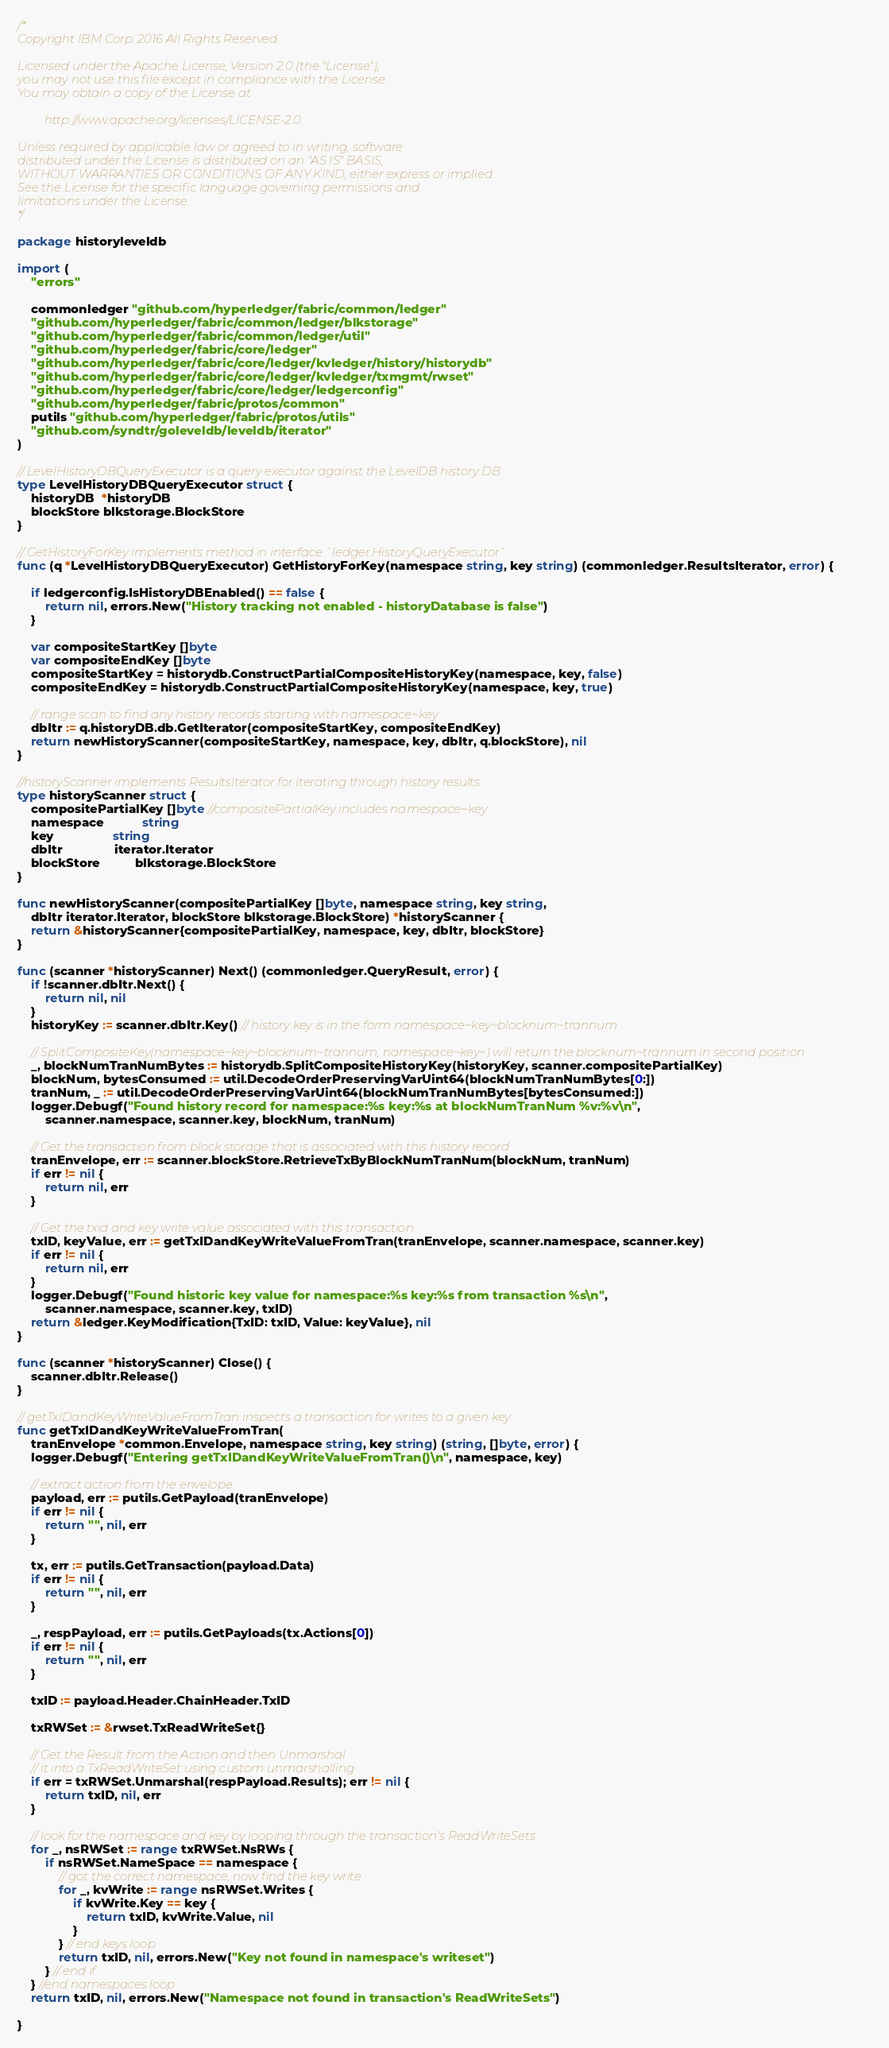Convert code to text. <code><loc_0><loc_0><loc_500><loc_500><_Go_>/*
Copyright IBM Corp. 2016 All Rights Reserved.

Licensed under the Apache License, Version 2.0 (the "License");
you may not use this file except in compliance with the License.
You may obtain a copy of the License at

		 http://www.apache.org/licenses/LICENSE-2.0

Unless required by applicable law or agreed to in writing, software
distributed under the License is distributed on an "AS IS" BASIS,
WITHOUT WARRANTIES OR CONDITIONS OF ANY KIND, either express or implied.
See the License for the specific language governing permissions and
limitations under the License.
*/

package historyleveldb

import (
	"errors"

	commonledger "github.com/hyperledger/fabric/common/ledger"
	"github.com/hyperledger/fabric/common/ledger/blkstorage"
	"github.com/hyperledger/fabric/common/ledger/util"
	"github.com/hyperledger/fabric/core/ledger"
	"github.com/hyperledger/fabric/core/ledger/kvledger/history/historydb"
	"github.com/hyperledger/fabric/core/ledger/kvledger/txmgmt/rwset"
	"github.com/hyperledger/fabric/core/ledger/ledgerconfig"
	"github.com/hyperledger/fabric/protos/common"
	putils "github.com/hyperledger/fabric/protos/utils"
	"github.com/syndtr/goleveldb/leveldb/iterator"
)

// LevelHistoryDBQueryExecutor is a query executor against the LevelDB history DB
type LevelHistoryDBQueryExecutor struct {
	historyDB  *historyDB
	blockStore blkstorage.BlockStore
}

// GetHistoryForKey implements method in interface `ledger.HistoryQueryExecutor`
func (q *LevelHistoryDBQueryExecutor) GetHistoryForKey(namespace string, key string) (commonledger.ResultsIterator, error) {

	if ledgerconfig.IsHistoryDBEnabled() == false {
		return nil, errors.New("History tracking not enabled - historyDatabase is false")
	}

	var compositeStartKey []byte
	var compositeEndKey []byte
	compositeStartKey = historydb.ConstructPartialCompositeHistoryKey(namespace, key, false)
	compositeEndKey = historydb.ConstructPartialCompositeHistoryKey(namespace, key, true)

	// range scan to find any history records starting with namespace~key
	dbItr := q.historyDB.db.GetIterator(compositeStartKey, compositeEndKey)
	return newHistoryScanner(compositeStartKey, namespace, key, dbItr, q.blockStore), nil
}

//historyScanner implements ResultsIterator for iterating through history results
type historyScanner struct {
	compositePartialKey []byte //compositePartialKey includes namespace~key
	namespace           string
	key                 string
	dbItr               iterator.Iterator
	blockStore          blkstorage.BlockStore
}

func newHistoryScanner(compositePartialKey []byte, namespace string, key string,
	dbItr iterator.Iterator, blockStore blkstorage.BlockStore) *historyScanner {
	return &historyScanner{compositePartialKey, namespace, key, dbItr, blockStore}
}

func (scanner *historyScanner) Next() (commonledger.QueryResult, error) {
	if !scanner.dbItr.Next() {
		return nil, nil
	}
	historyKey := scanner.dbItr.Key() // history key is in the form namespace~key~blocknum~trannum

	// SplitCompositeKey(namespace~key~blocknum~trannum, namespace~key~) will return the blocknum~trannum in second position
	_, blockNumTranNumBytes := historydb.SplitCompositeHistoryKey(historyKey, scanner.compositePartialKey)
	blockNum, bytesConsumed := util.DecodeOrderPreservingVarUint64(blockNumTranNumBytes[0:])
	tranNum, _ := util.DecodeOrderPreservingVarUint64(blockNumTranNumBytes[bytesConsumed:])
	logger.Debugf("Found history record for namespace:%s key:%s at blockNumTranNum %v:%v\n",
		scanner.namespace, scanner.key, blockNum, tranNum)

	// Get the transaction from block storage that is associated with this history record
	tranEnvelope, err := scanner.blockStore.RetrieveTxByBlockNumTranNum(blockNum, tranNum)
	if err != nil {
		return nil, err
	}

	// Get the txid and key write value associated with this transaction
	txID, keyValue, err := getTxIDandKeyWriteValueFromTran(tranEnvelope, scanner.namespace, scanner.key)
	if err != nil {
		return nil, err
	}
	logger.Debugf("Found historic key value for namespace:%s key:%s from transaction %s\n",
		scanner.namespace, scanner.key, txID)
	return &ledger.KeyModification{TxID: txID, Value: keyValue}, nil
}

func (scanner *historyScanner) Close() {
	scanner.dbItr.Release()
}

// getTxIDandKeyWriteValueFromTran inspects a transaction for writes to a given key
func getTxIDandKeyWriteValueFromTran(
	tranEnvelope *common.Envelope, namespace string, key string) (string, []byte, error) {
	logger.Debugf("Entering getTxIDandKeyWriteValueFromTran()\n", namespace, key)

	// extract action from the envelope
	payload, err := putils.GetPayload(tranEnvelope)
	if err != nil {
		return "", nil, err
	}

	tx, err := putils.GetTransaction(payload.Data)
	if err != nil {
		return "", nil, err
	}

	_, respPayload, err := putils.GetPayloads(tx.Actions[0])
	if err != nil {
		return "", nil, err
	}

	txID := payload.Header.ChainHeader.TxID

	txRWSet := &rwset.TxReadWriteSet{}

	// Get the Result from the Action and then Unmarshal
	// it into a TxReadWriteSet using custom unmarshalling
	if err = txRWSet.Unmarshal(respPayload.Results); err != nil {
		return txID, nil, err
	}

	// look for the namespace and key by looping through the transaction's ReadWriteSets
	for _, nsRWSet := range txRWSet.NsRWs {
		if nsRWSet.NameSpace == namespace {
			// got the correct namespace, now find the key write
			for _, kvWrite := range nsRWSet.Writes {
				if kvWrite.Key == key {
					return txID, kvWrite.Value, nil
				}
			} // end keys loop
			return txID, nil, errors.New("Key not found in namespace's writeset")
		} // end if
	} //end namespaces loop
	return txID, nil, errors.New("Namespace not found in transaction's ReadWriteSets")

}
</code> 